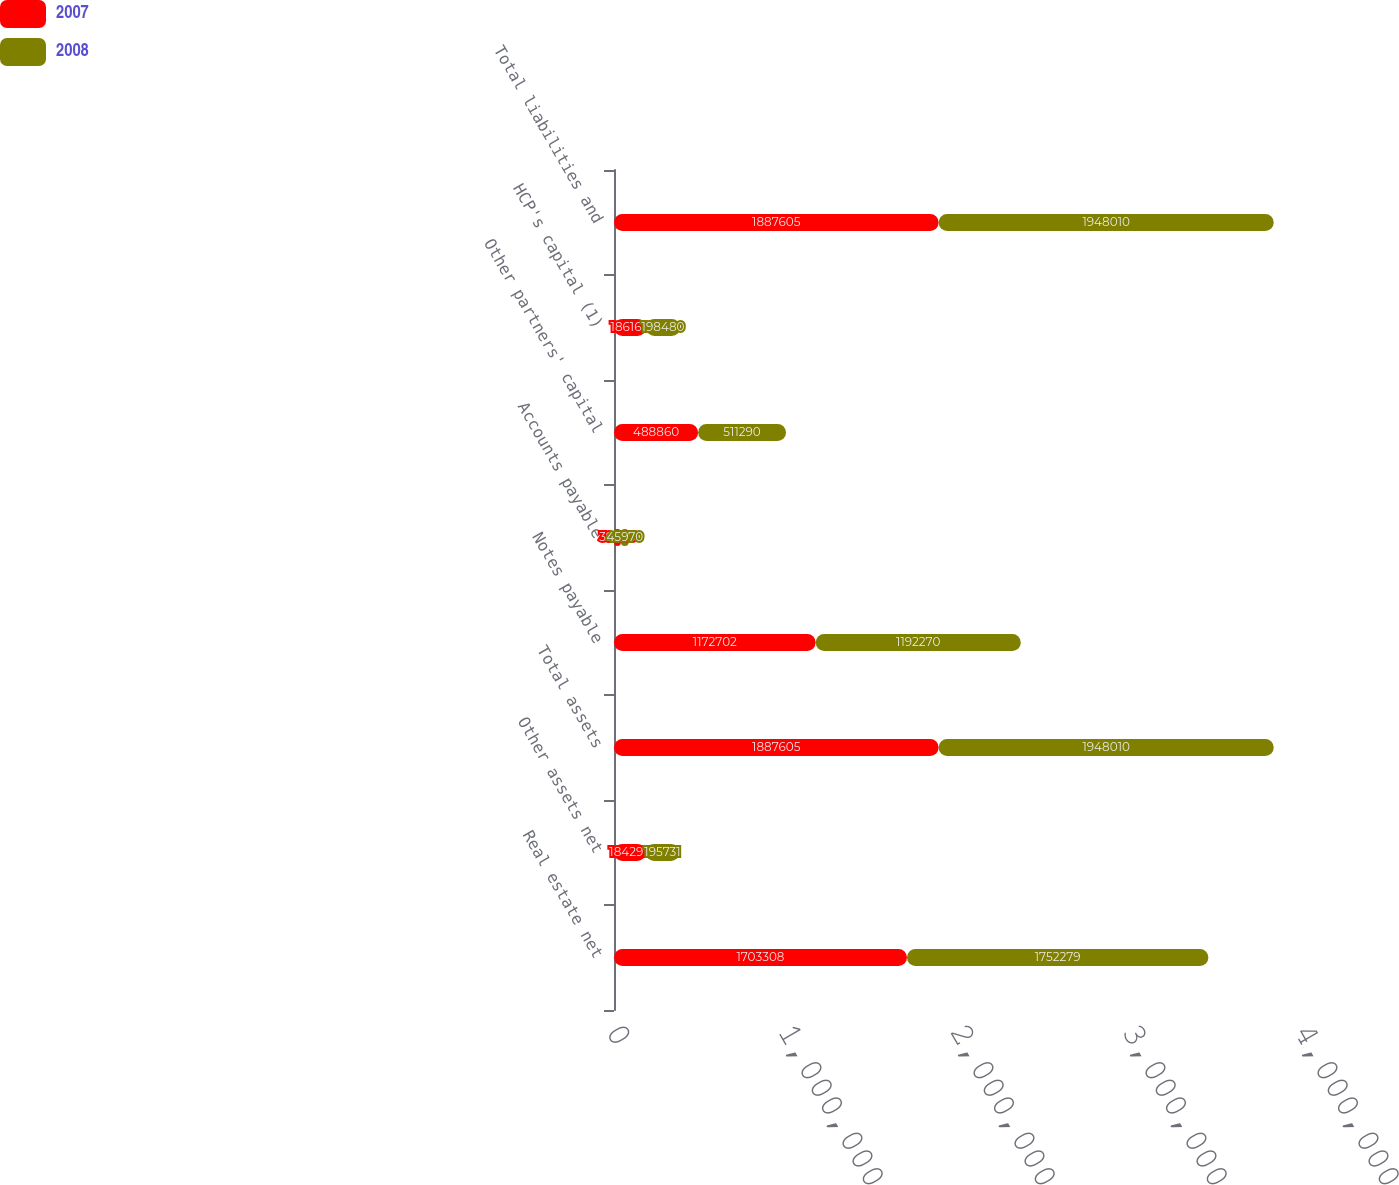Convert chart to OTSL. <chart><loc_0><loc_0><loc_500><loc_500><stacked_bar_chart><ecel><fcel>Real estate net<fcel>Other assets net<fcel>Total assets<fcel>Notes payable<fcel>Accounts payable<fcel>Other partners' capital<fcel>HCP's capital (1)<fcel>Total liabilities and<nl><fcel>2007<fcel>1.70331e+06<fcel>184297<fcel>1.8876e+06<fcel>1.1727e+06<fcel>39883<fcel>488860<fcel>186160<fcel>1.8876e+06<nl><fcel>2008<fcel>1.75228e+06<fcel>195731<fcel>1.94801e+06<fcel>1.19227e+06<fcel>45970<fcel>511290<fcel>198480<fcel>1.94801e+06<nl></chart> 